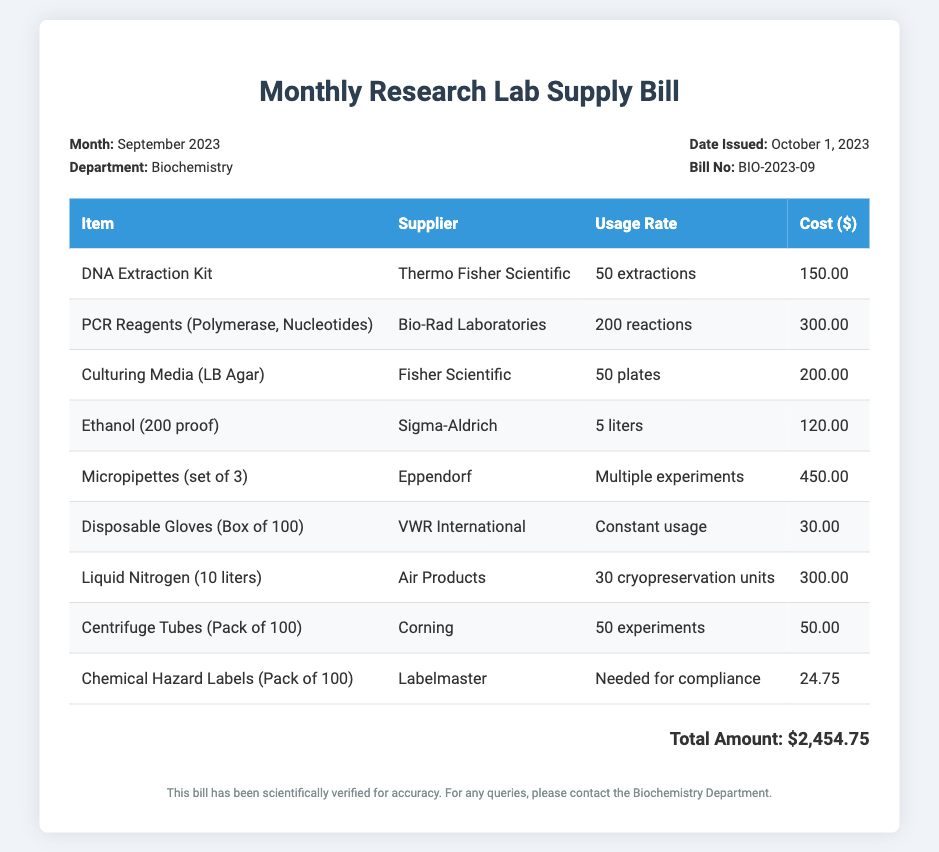what is the total amount of the bill? The total amount is displayed at the bottom of the document as the sum of all item costs, which is $2,454.75.
Answer: $2,454.75 who is the supplier for the DNA Extraction Kit? The supplier is found in the itemization of costs in the table, which lists Thermo Fisher Scientific for the DNA Extraction Kit.
Answer: Thermo Fisher Scientific how many reactions can be done with the PCR Reagents? The usage rate listed in the table indicates that 200 reactions can be performed with the PCR Reagents.
Answer: 200 reactions what is the date the bill was issued? The date issued is mentioned in the bill information section, which states October 1, 2023.
Answer: October 1, 2023 which item has the highest cost? The item with the highest cost can be inferred from the cost column in the table, which shows that Micropipettes (set of 3) is $450.00.
Answer: Micropipettes (set of 3) how many liters of liquid nitrogen were supplied? The quantity supplied is specified in the table as 10 liters of liquid nitrogen.
Answer: 10 liters what is the purpose of the Chemical Hazard Labels? The purpose is indicated in the usage description, stating they are needed for compliance.
Answer: Needed for compliance how many disposable gloves are in a box? The document states that there are 100 disposable gloves in a box from the itemized list.
Answer: Box of 100 